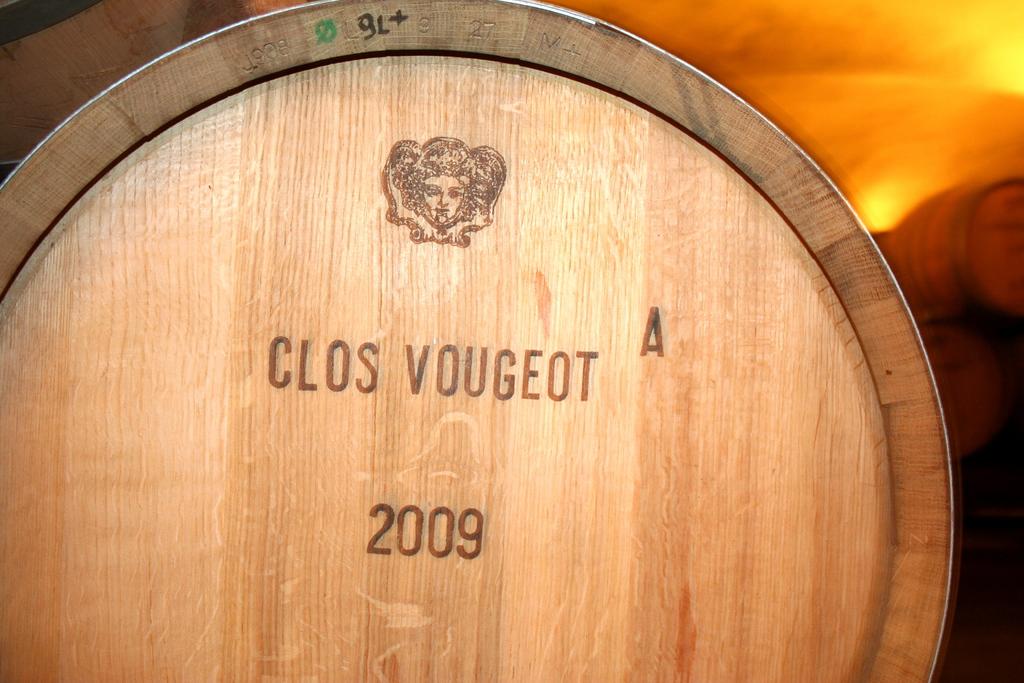In what year was the alcohol made?
Provide a short and direct response. 2009. Is clos vougeot a french wine?
Your response must be concise. Unanswerable. 